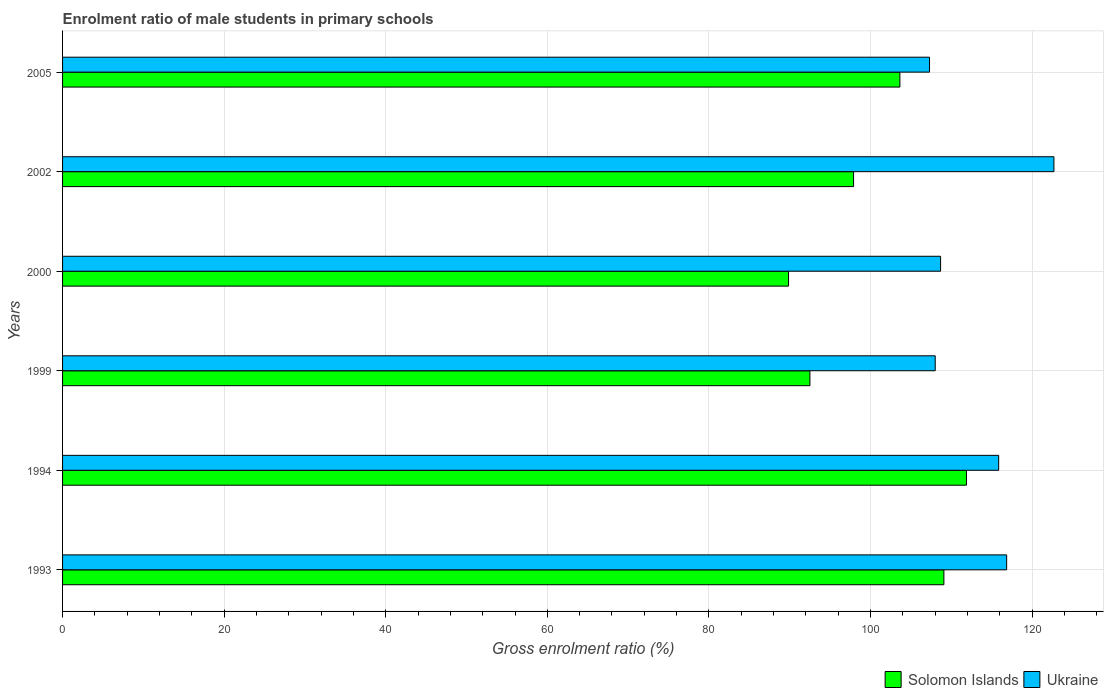How many different coloured bars are there?
Your answer should be compact. 2. How many bars are there on the 2nd tick from the top?
Provide a short and direct response. 2. How many bars are there on the 5th tick from the bottom?
Offer a very short reply. 2. What is the label of the 2nd group of bars from the top?
Your answer should be very brief. 2002. In how many cases, is the number of bars for a given year not equal to the number of legend labels?
Provide a short and direct response. 0. What is the enrolment ratio of male students in primary schools in Ukraine in 2005?
Your answer should be very brief. 107.3. Across all years, what is the maximum enrolment ratio of male students in primary schools in Solomon Islands?
Make the answer very short. 111.87. Across all years, what is the minimum enrolment ratio of male students in primary schools in Ukraine?
Your answer should be very brief. 107.3. In which year was the enrolment ratio of male students in primary schools in Ukraine maximum?
Provide a short and direct response. 2002. In which year was the enrolment ratio of male students in primary schools in Ukraine minimum?
Offer a very short reply. 2005. What is the total enrolment ratio of male students in primary schools in Solomon Islands in the graph?
Offer a terse response. 604.84. What is the difference between the enrolment ratio of male students in primary schools in Solomon Islands in 1993 and that in 1994?
Offer a very short reply. -2.79. What is the difference between the enrolment ratio of male students in primary schools in Solomon Islands in 1994 and the enrolment ratio of male students in primary schools in Ukraine in 2002?
Provide a succinct answer. -10.83. What is the average enrolment ratio of male students in primary schools in Ukraine per year?
Your answer should be very brief. 113.23. In the year 1994, what is the difference between the enrolment ratio of male students in primary schools in Ukraine and enrolment ratio of male students in primary schools in Solomon Islands?
Your answer should be compact. 3.99. What is the ratio of the enrolment ratio of male students in primary schools in Ukraine in 1993 to that in 2002?
Your response must be concise. 0.95. What is the difference between the highest and the second highest enrolment ratio of male students in primary schools in Solomon Islands?
Offer a very short reply. 2.79. What is the difference between the highest and the lowest enrolment ratio of male students in primary schools in Solomon Islands?
Ensure brevity in your answer.  22.02. Is the sum of the enrolment ratio of male students in primary schools in Ukraine in 2000 and 2002 greater than the maximum enrolment ratio of male students in primary schools in Solomon Islands across all years?
Ensure brevity in your answer.  Yes. What does the 2nd bar from the top in 1999 represents?
Give a very brief answer. Solomon Islands. What does the 1st bar from the bottom in 1999 represents?
Offer a very short reply. Solomon Islands. Are all the bars in the graph horizontal?
Your answer should be compact. Yes. How many years are there in the graph?
Keep it short and to the point. 6. Does the graph contain any zero values?
Offer a terse response. No. Does the graph contain grids?
Provide a short and direct response. Yes. How many legend labels are there?
Your answer should be very brief. 2. How are the legend labels stacked?
Provide a short and direct response. Horizontal. What is the title of the graph?
Offer a very short reply. Enrolment ratio of male students in primary schools. Does "Liechtenstein" appear as one of the legend labels in the graph?
Keep it short and to the point. No. What is the label or title of the X-axis?
Provide a short and direct response. Gross enrolment ratio (%). What is the label or title of the Y-axis?
Make the answer very short. Years. What is the Gross enrolment ratio (%) of Solomon Islands in 1993?
Keep it short and to the point. 109.08. What is the Gross enrolment ratio (%) in Ukraine in 1993?
Offer a very short reply. 116.85. What is the Gross enrolment ratio (%) in Solomon Islands in 1994?
Your answer should be very brief. 111.87. What is the Gross enrolment ratio (%) of Ukraine in 1994?
Your response must be concise. 115.86. What is the Gross enrolment ratio (%) in Solomon Islands in 1999?
Offer a very short reply. 92.5. What is the Gross enrolment ratio (%) in Ukraine in 1999?
Offer a very short reply. 108.01. What is the Gross enrolment ratio (%) in Solomon Islands in 2000?
Give a very brief answer. 89.85. What is the Gross enrolment ratio (%) of Ukraine in 2000?
Keep it short and to the point. 108.67. What is the Gross enrolment ratio (%) of Solomon Islands in 2002?
Keep it short and to the point. 97.9. What is the Gross enrolment ratio (%) of Ukraine in 2002?
Offer a very short reply. 122.7. What is the Gross enrolment ratio (%) in Solomon Islands in 2005?
Provide a short and direct response. 103.63. What is the Gross enrolment ratio (%) in Ukraine in 2005?
Offer a terse response. 107.3. Across all years, what is the maximum Gross enrolment ratio (%) of Solomon Islands?
Your response must be concise. 111.87. Across all years, what is the maximum Gross enrolment ratio (%) of Ukraine?
Your answer should be very brief. 122.7. Across all years, what is the minimum Gross enrolment ratio (%) in Solomon Islands?
Provide a succinct answer. 89.85. Across all years, what is the minimum Gross enrolment ratio (%) of Ukraine?
Your answer should be very brief. 107.3. What is the total Gross enrolment ratio (%) in Solomon Islands in the graph?
Provide a succinct answer. 604.84. What is the total Gross enrolment ratio (%) in Ukraine in the graph?
Provide a succinct answer. 679.39. What is the difference between the Gross enrolment ratio (%) of Solomon Islands in 1993 and that in 1994?
Your response must be concise. -2.79. What is the difference between the Gross enrolment ratio (%) of Ukraine in 1993 and that in 1994?
Provide a short and direct response. 0.99. What is the difference between the Gross enrolment ratio (%) in Solomon Islands in 1993 and that in 1999?
Your answer should be compact. 16.58. What is the difference between the Gross enrolment ratio (%) of Ukraine in 1993 and that in 1999?
Your answer should be compact. 8.84. What is the difference between the Gross enrolment ratio (%) of Solomon Islands in 1993 and that in 2000?
Your answer should be compact. 19.23. What is the difference between the Gross enrolment ratio (%) of Ukraine in 1993 and that in 2000?
Keep it short and to the point. 8.18. What is the difference between the Gross enrolment ratio (%) of Solomon Islands in 1993 and that in 2002?
Your answer should be very brief. 11.18. What is the difference between the Gross enrolment ratio (%) in Ukraine in 1993 and that in 2002?
Provide a short and direct response. -5.85. What is the difference between the Gross enrolment ratio (%) of Solomon Islands in 1993 and that in 2005?
Your answer should be very brief. 5.45. What is the difference between the Gross enrolment ratio (%) in Ukraine in 1993 and that in 2005?
Provide a short and direct response. 9.55. What is the difference between the Gross enrolment ratio (%) of Solomon Islands in 1994 and that in 1999?
Ensure brevity in your answer.  19.37. What is the difference between the Gross enrolment ratio (%) in Ukraine in 1994 and that in 1999?
Make the answer very short. 7.85. What is the difference between the Gross enrolment ratio (%) in Solomon Islands in 1994 and that in 2000?
Your answer should be compact. 22.02. What is the difference between the Gross enrolment ratio (%) of Ukraine in 1994 and that in 2000?
Your response must be concise. 7.19. What is the difference between the Gross enrolment ratio (%) of Solomon Islands in 1994 and that in 2002?
Ensure brevity in your answer.  13.97. What is the difference between the Gross enrolment ratio (%) in Ukraine in 1994 and that in 2002?
Provide a succinct answer. -6.84. What is the difference between the Gross enrolment ratio (%) in Solomon Islands in 1994 and that in 2005?
Offer a terse response. 8.24. What is the difference between the Gross enrolment ratio (%) of Ukraine in 1994 and that in 2005?
Provide a succinct answer. 8.56. What is the difference between the Gross enrolment ratio (%) in Solomon Islands in 1999 and that in 2000?
Make the answer very short. 2.65. What is the difference between the Gross enrolment ratio (%) in Ukraine in 1999 and that in 2000?
Your answer should be very brief. -0.66. What is the difference between the Gross enrolment ratio (%) of Solomon Islands in 1999 and that in 2002?
Ensure brevity in your answer.  -5.4. What is the difference between the Gross enrolment ratio (%) of Ukraine in 1999 and that in 2002?
Your answer should be very brief. -14.69. What is the difference between the Gross enrolment ratio (%) in Solomon Islands in 1999 and that in 2005?
Make the answer very short. -11.13. What is the difference between the Gross enrolment ratio (%) in Ukraine in 1999 and that in 2005?
Keep it short and to the point. 0.7. What is the difference between the Gross enrolment ratio (%) in Solomon Islands in 2000 and that in 2002?
Your answer should be very brief. -8.05. What is the difference between the Gross enrolment ratio (%) of Ukraine in 2000 and that in 2002?
Offer a terse response. -14.03. What is the difference between the Gross enrolment ratio (%) in Solomon Islands in 2000 and that in 2005?
Offer a very short reply. -13.78. What is the difference between the Gross enrolment ratio (%) of Ukraine in 2000 and that in 2005?
Keep it short and to the point. 1.37. What is the difference between the Gross enrolment ratio (%) of Solomon Islands in 2002 and that in 2005?
Give a very brief answer. -5.73. What is the difference between the Gross enrolment ratio (%) in Ukraine in 2002 and that in 2005?
Offer a very short reply. 15.4. What is the difference between the Gross enrolment ratio (%) in Solomon Islands in 1993 and the Gross enrolment ratio (%) in Ukraine in 1994?
Offer a terse response. -6.78. What is the difference between the Gross enrolment ratio (%) in Solomon Islands in 1993 and the Gross enrolment ratio (%) in Ukraine in 1999?
Keep it short and to the point. 1.07. What is the difference between the Gross enrolment ratio (%) in Solomon Islands in 1993 and the Gross enrolment ratio (%) in Ukraine in 2000?
Keep it short and to the point. 0.41. What is the difference between the Gross enrolment ratio (%) of Solomon Islands in 1993 and the Gross enrolment ratio (%) of Ukraine in 2002?
Offer a very short reply. -13.62. What is the difference between the Gross enrolment ratio (%) in Solomon Islands in 1993 and the Gross enrolment ratio (%) in Ukraine in 2005?
Provide a succinct answer. 1.78. What is the difference between the Gross enrolment ratio (%) in Solomon Islands in 1994 and the Gross enrolment ratio (%) in Ukraine in 1999?
Keep it short and to the point. 3.87. What is the difference between the Gross enrolment ratio (%) in Solomon Islands in 1994 and the Gross enrolment ratio (%) in Ukraine in 2000?
Offer a terse response. 3.2. What is the difference between the Gross enrolment ratio (%) of Solomon Islands in 1994 and the Gross enrolment ratio (%) of Ukraine in 2002?
Offer a very short reply. -10.83. What is the difference between the Gross enrolment ratio (%) in Solomon Islands in 1994 and the Gross enrolment ratio (%) in Ukraine in 2005?
Provide a short and direct response. 4.57. What is the difference between the Gross enrolment ratio (%) in Solomon Islands in 1999 and the Gross enrolment ratio (%) in Ukraine in 2000?
Your answer should be compact. -16.17. What is the difference between the Gross enrolment ratio (%) of Solomon Islands in 1999 and the Gross enrolment ratio (%) of Ukraine in 2002?
Your response must be concise. -30.2. What is the difference between the Gross enrolment ratio (%) of Solomon Islands in 1999 and the Gross enrolment ratio (%) of Ukraine in 2005?
Keep it short and to the point. -14.8. What is the difference between the Gross enrolment ratio (%) of Solomon Islands in 2000 and the Gross enrolment ratio (%) of Ukraine in 2002?
Ensure brevity in your answer.  -32.84. What is the difference between the Gross enrolment ratio (%) of Solomon Islands in 2000 and the Gross enrolment ratio (%) of Ukraine in 2005?
Your answer should be very brief. -17.45. What is the difference between the Gross enrolment ratio (%) in Solomon Islands in 2002 and the Gross enrolment ratio (%) in Ukraine in 2005?
Give a very brief answer. -9.4. What is the average Gross enrolment ratio (%) in Solomon Islands per year?
Ensure brevity in your answer.  100.81. What is the average Gross enrolment ratio (%) in Ukraine per year?
Provide a short and direct response. 113.23. In the year 1993, what is the difference between the Gross enrolment ratio (%) in Solomon Islands and Gross enrolment ratio (%) in Ukraine?
Offer a terse response. -7.77. In the year 1994, what is the difference between the Gross enrolment ratio (%) in Solomon Islands and Gross enrolment ratio (%) in Ukraine?
Your answer should be very brief. -3.99. In the year 1999, what is the difference between the Gross enrolment ratio (%) of Solomon Islands and Gross enrolment ratio (%) of Ukraine?
Offer a very short reply. -15.51. In the year 2000, what is the difference between the Gross enrolment ratio (%) in Solomon Islands and Gross enrolment ratio (%) in Ukraine?
Offer a terse response. -18.82. In the year 2002, what is the difference between the Gross enrolment ratio (%) in Solomon Islands and Gross enrolment ratio (%) in Ukraine?
Offer a terse response. -24.8. In the year 2005, what is the difference between the Gross enrolment ratio (%) of Solomon Islands and Gross enrolment ratio (%) of Ukraine?
Offer a very short reply. -3.67. What is the ratio of the Gross enrolment ratio (%) in Ukraine in 1993 to that in 1994?
Ensure brevity in your answer.  1.01. What is the ratio of the Gross enrolment ratio (%) in Solomon Islands in 1993 to that in 1999?
Your answer should be compact. 1.18. What is the ratio of the Gross enrolment ratio (%) of Ukraine in 1993 to that in 1999?
Provide a succinct answer. 1.08. What is the ratio of the Gross enrolment ratio (%) of Solomon Islands in 1993 to that in 2000?
Keep it short and to the point. 1.21. What is the ratio of the Gross enrolment ratio (%) of Ukraine in 1993 to that in 2000?
Offer a very short reply. 1.08. What is the ratio of the Gross enrolment ratio (%) in Solomon Islands in 1993 to that in 2002?
Make the answer very short. 1.11. What is the ratio of the Gross enrolment ratio (%) of Ukraine in 1993 to that in 2002?
Make the answer very short. 0.95. What is the ratio of the Gross enrolment ratio (%) in Solomon Islands in 1993 to that in 2005?
Provide a short and direct response. 1.05. What is the ratio of the Gross enrolment ratio (%) of Ukraine in 1993 to that in 2005?
Offer a terse response. 1.09. What is the ratio of the Gross enrolment ratio (%) of Solomon Islands in 1994 to that in 1999?
Your answer should be compact. 1.21. What is the ratio of the Gross enrolment ratio (%) of Ukraine in 1994 to that in 1999?
Keep it short and to the point. 1.07. What is the ratio of the Gross enrolment ratio (%) of Solomon Islands in 1994 to that in 2000?
Give a very brief answer. 1.25. What is the ratio of the Gross enrolment ratio (%) in Ukraine in 1994 to that in 2000?
Provide a short and direct response. 1.07. What is the ratio of the Gross enrolment ratio (%) of Solomon Islands in 1994 to that in 2002?
Give a very brief answer. 1.14. What is the ratio of the Gross enrolment ratio (%) in Ukraine in 1994 to that in 2002?
Give a very brief answer. 0.94. What is the ratio of the Gross enrolment ratio (%) in Solomon Islands in 1994 to that in 2005?
Your answer should be very brief. 1.08. What is the ratio of the Gross enrolment ratio (%) in Ukraine in 1994 to that in 2005?
Offer a very short reply. 1.08. What is the ratio of the Gross enrolment ratio (%) in Solomon Islands in 1999 to that in 2000?
Your answer should be compact. 1.03. What is the ratio of the Gross enrolment ratio (%) of Solomon Islands in 1999 to that in 2002?
Keep it short and to the point. 0.94. What is the ratio of the Gross enrolment ratio (%) of Ukraine in 1999 to that in 2002?
Ensure brevity in your answer.  0.88. What is the ratio of the Gross enrolment ratio (%) in Solomon Islands in 1999 to that in 2005?
Provide a short and direct response. 0.89. What is the ratio of the Gross enrolment ratio (%) of Ukraine in 1999 to that in 2005?
Give a very brief answer. 1.01. What is the ratio of the Gross enrolment ratio (%) of Solomon Islands in 2000 to that in 2002?
Ensure brevity in your answer.  0.92. What is the ratio of the Gross enrolment ratio (%) of Ukraine in 2000 to that in 2002?
Your answer should be very brief. 0.89. What is the ratio of the Gross enrolment ratio (%) in Solomon Islands in 2000 to that in 2005?
Your answer should be very brief. 0.87. What is the ratio of the Gross enrolment ratio (%) of Ukraine in 2000 to that in 2005?
Your answer should be very brief. 1.01. What is the ratio of the Gross enrolment ratio (%) of Solomon Islands in 2002 to that in 2005?
Your response must be concise. 0.94. What is the ratio of the Gross enrolment ratio (%) of Ukraine in 2002 to that in 2005?
Make the answer very short. 1.14. What is the difference between the highest and the second highest Gross enrolment ratio (%) of Solomon Islands?
Offer a very short reply. 2.79. What is the difference between the highest and the second highest Gross enrolment ratio (%) of Ukraine?
Give a very brief answer. 5.85. What is the difference between the highest and the lowest Gross enrolment ratio (%) of Solomon Islands?
Keep it short and to the point. 22.02. What is the difference between the highest and the lowest Gross enrolment ratio (%) in Ukraine?
Your response must be concise. 15.4. 